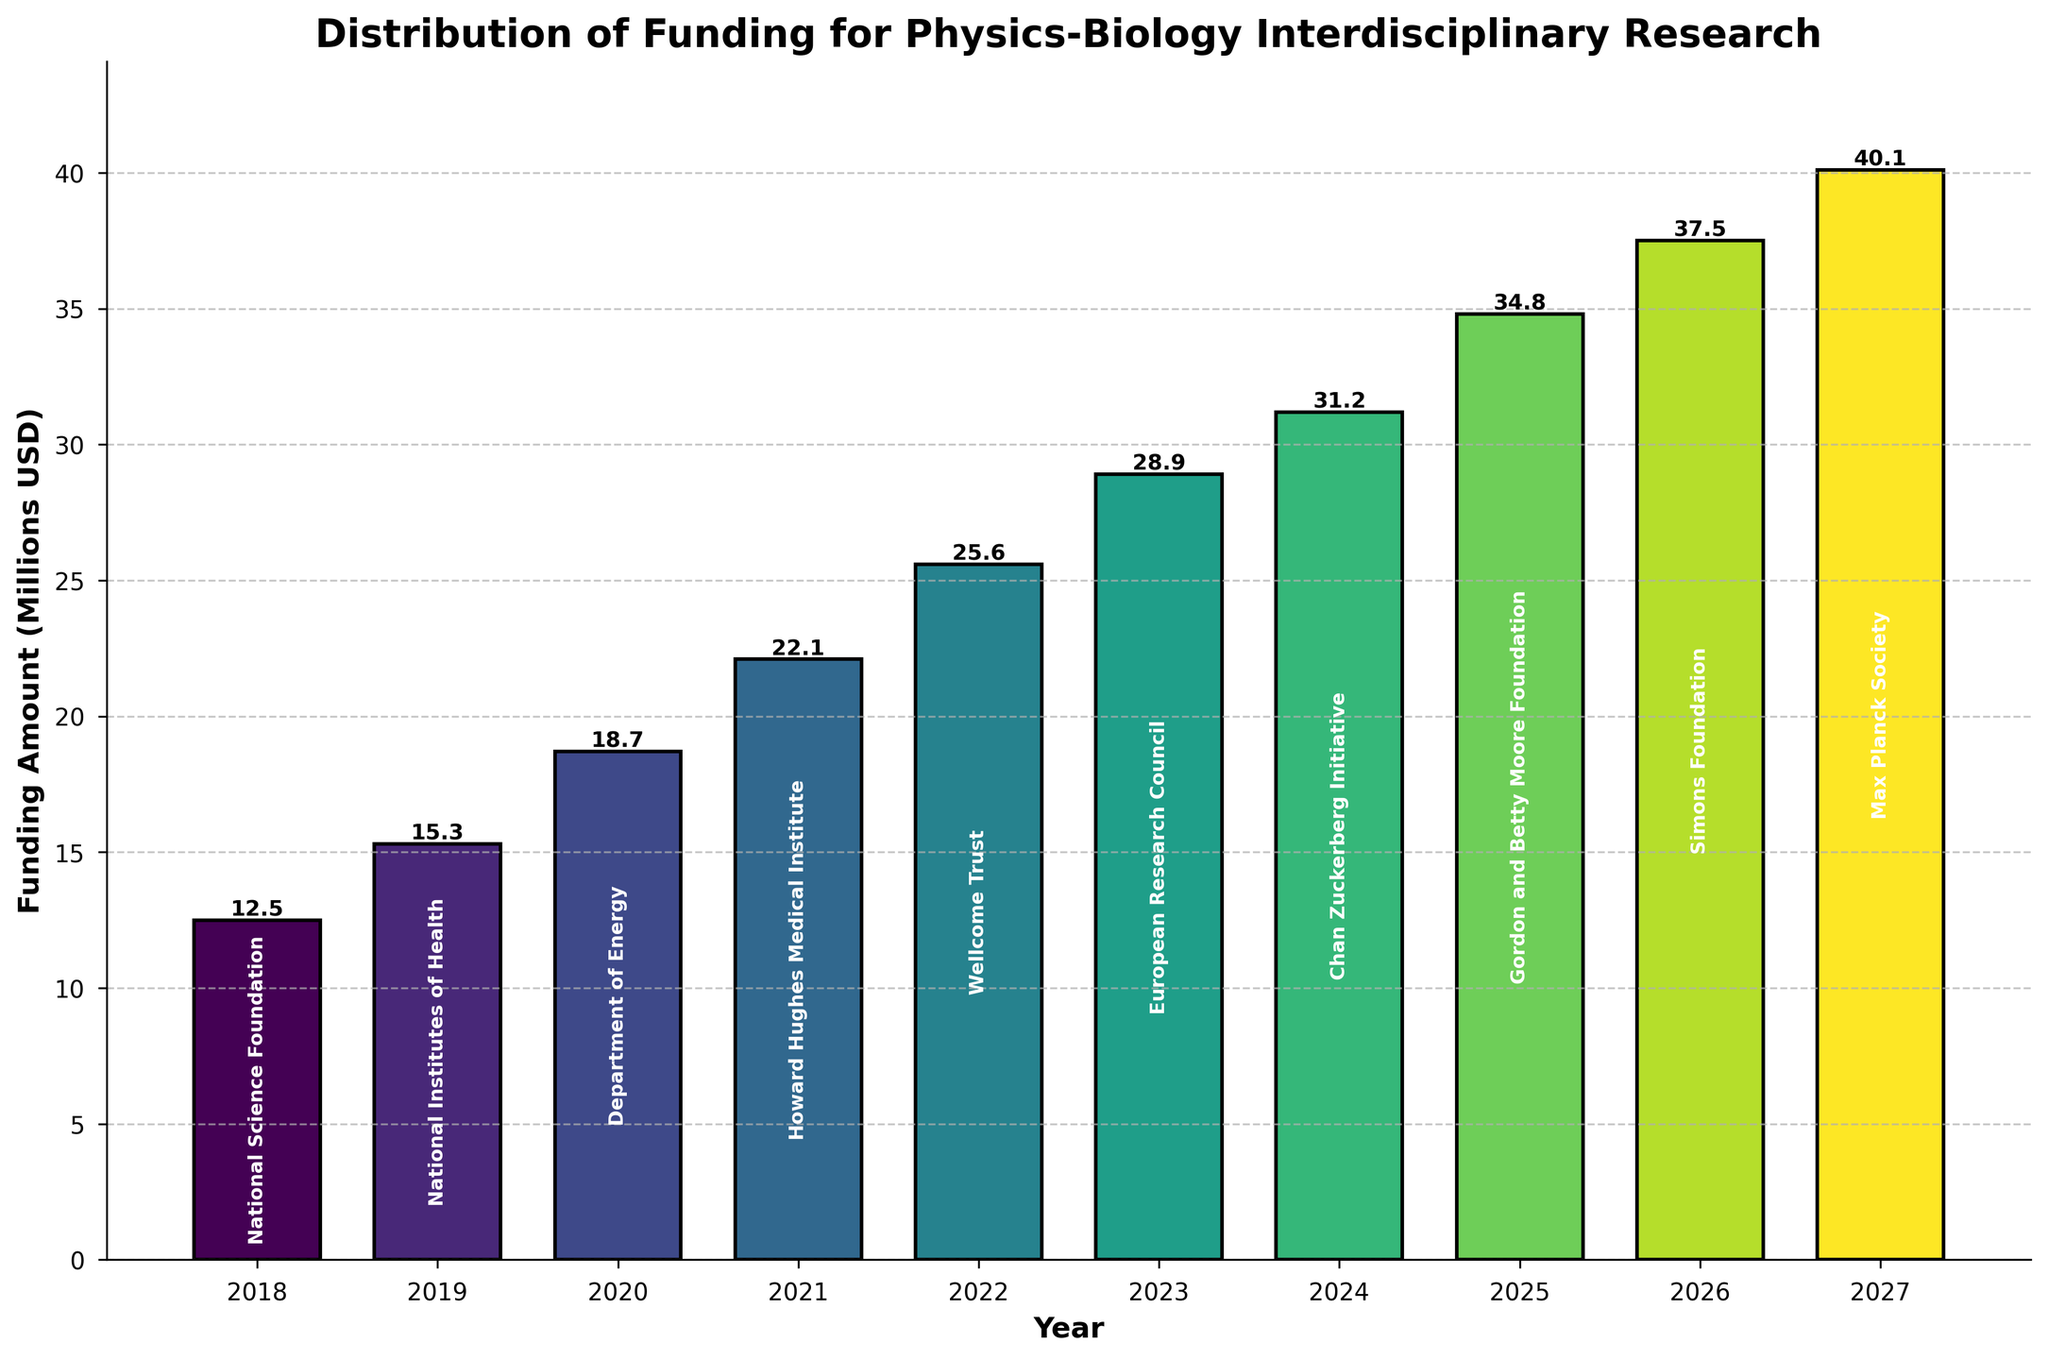Which year had the highest funding amount? To find the highest funding amount, look for the bar with the greatest height. The year label below that bar represents the year with the highest funding. The bar representing 2027 has the highest height.
Answer: 2027 Which funding agency provided the second-highest funding amount? To determine the second-highest funding amount, look for the second tallest bar and read the agency label within the bar. The bar representing 2026 has the second highest height, and the label inside it is "Simons Foundation".
Answer: Simons Foundation What is the total funding amount from 2023 to 2025? Add the funding amounts for the years 2023, 2024, and 2025. The funding amounts are 28.9, 31.2, and 34.8 million USD respectively. Sum them up: 28.9 + 31.2 + 34.8 = 94.9 million USD.
Answer: 94.9 million USD How much more funding was allocated in 2021 compared to 2019? Find the funding amounts for 2021 and 2019 and calculate their difference. The funding amounts are 22.1 million USD for 2021 and 15.3 million USD for 2019. Subtract 15.3 from 22.1: 22.1 - 15.3 = 6.8 million USD.
Answer: 6.8 million USD Which year had the smallest increase in funding compared to the previous year? Calculate the yearly changes in funding by subtracting each year's funding amount from the previous year's. Identify the smallest difference. The yearly changes are: 2019 - 2018: 15.3 - 12.5 = 2.8, 2020 - 2019: 18.7 - 15.3 = 3.4, 2021 - 2020: 22.1 - 18.7 = 3.4, 2022 - 2021: 25.6 - 22.1 = 3.5, 2023 - 2022: 28.9 - 25.6 = 3.3, 2024 - 2023: 31.2 - 28.9 = 2.3, 2025 - 2024: 34.8 - 31.2 = 3.6, 2026 - 2025: 37.5 - 34.8 = 2.7, 2027 - 2026: 40.1 - 37.5 = 2.6. The smallest increase is 2.3 million USD from 2023 to 2024.
Answer: 2024 What is the average funding amount from 2018 to 2027? Calculate the sum of the funding amounts from 2018 to 2027 and then divide by the number of years (10). The funding amounts are 12.5, 15.3, 18.7, 22.1, 25.6, 28.9, 31.2, 34.8, 37.5, and 40.1 million USD. The sum is 266.7 million USD, and the average is 266.7 / 10 = 26.67 million USD.
Answer: 26.67 million USD 